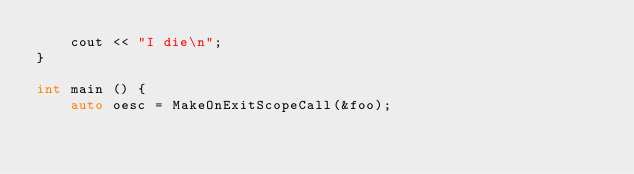<code> <loc_0><loc_0><loc_500><loc_500><_C++_>    cout << "I die\n";
}

int main () {
    auto oesc = MakeOnExitScopeCall(&foo);</code> 